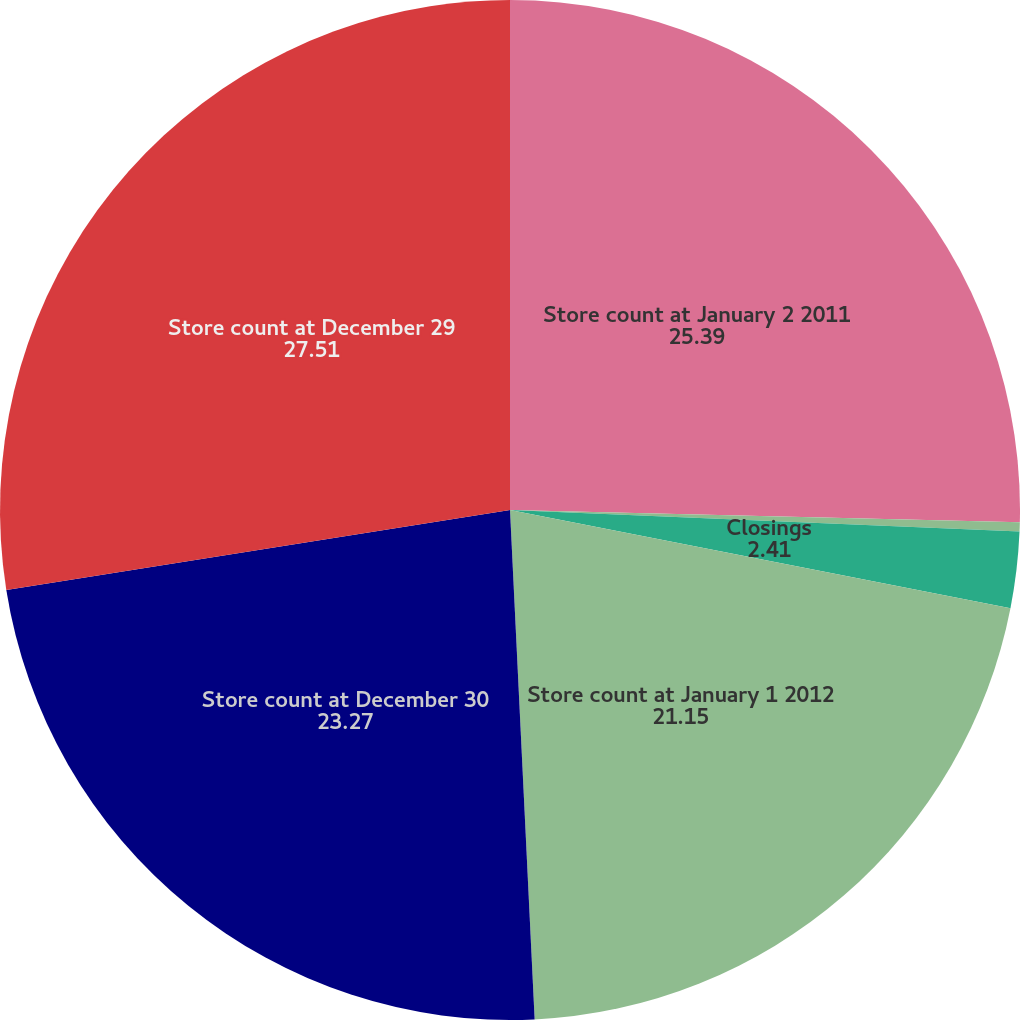Convert chart. <chart><loc_0><loc_0><loc_500><loc_500><pie_chart><fcel>Store count at January 2 2011<fcel>Openings<fcel>Closings<fcel>Store count at January 1 2012<fcel>Store count at December 30<fcel>Store count at December 29<nl><fcel>25.39%<fcel>0.29%<fcel>2.41%<fcel>21.15%<fcel>23.27%<fcel>27.51%<nl></chart> 